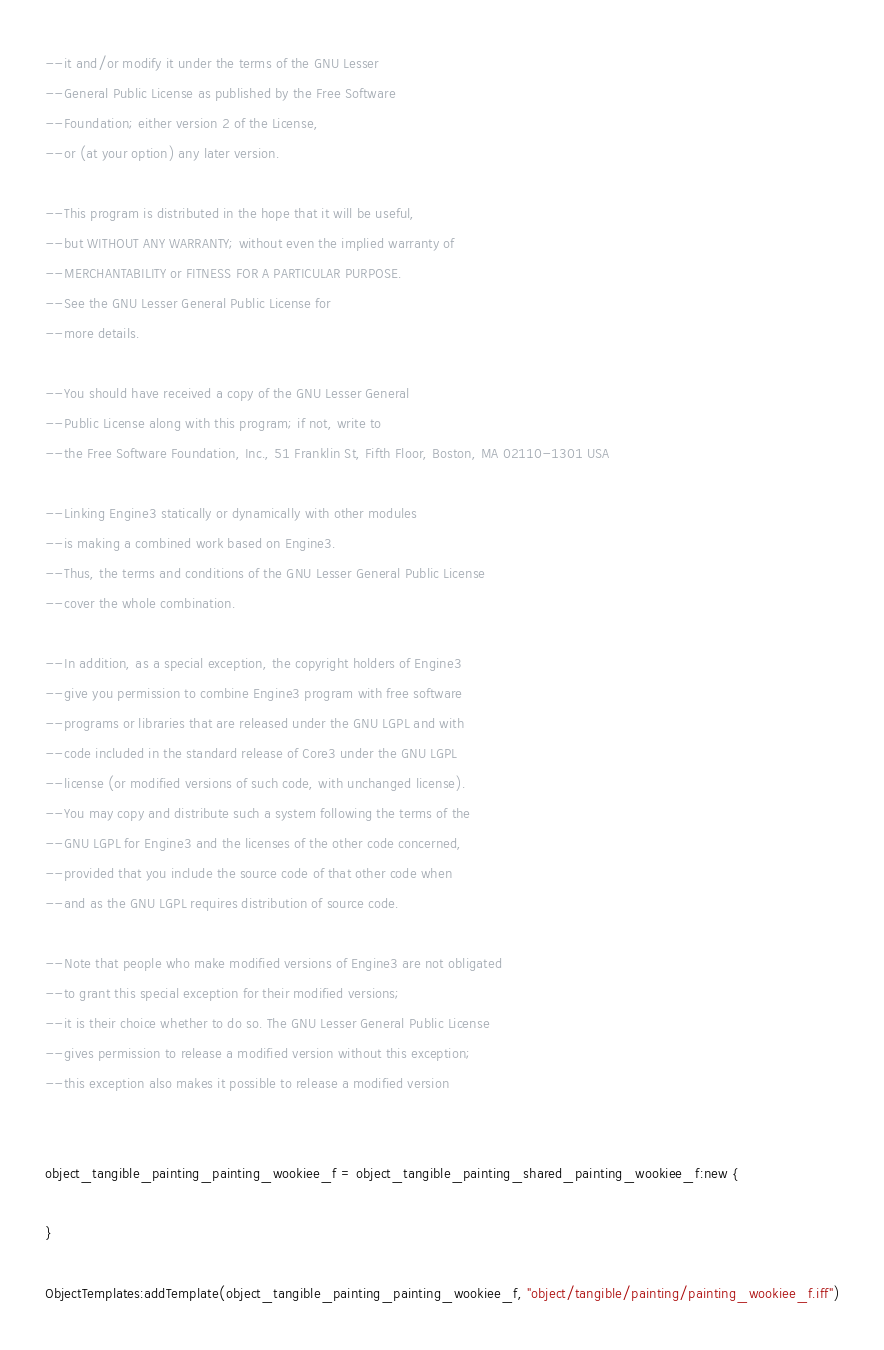<code> <loc_0><loc_0><loc_500><loc_500><_Lua_>--it and/or modify it under the terms of the GNU Lesser 
--General Public License as published by the Free Software
--Foundation; either version 2 of the License, 
--or (at your option) any later version.

--This program is distributed in the hope that it will be useful, 
--but WITHOUT ANY WARRANTY; without even the implied warranty of 
--MERCHANTABILITY or FITNESS FOR A PARTICULAR PURPOSE. 
--See the GNU Lesser General Public License for
--more details.

--You should have received a copy of the GNU Lesser General 
--Public License along with this program; if not, write to
--the Free Software Foundation, Inc., 51 Franklin St, Fifth Floor, Boston, MA 02110-1301 USA

--Linking Engine3 statically or dynamically with other modules 
--is making a combined work based on Engine3. 
--Thus, the terms and conditions of the GNU Lesser General Public License 
--cover the whole combination.

--In addition, as a special exception, the copyright holders of Engine3 
--give you permission to combine Engine3 program with free software 
--programs or libraries that are released under the GNU LGPL and with 
--code included in the standard release of Core3 under the GNU LGPL 
--license (or modified versions of such code, with unchanged license). 
--You may copy and distribute such a system following the terms of the 
--GNU LGPL for Engine3 and the licenses of the other code concerned, 
--provided that you include the source code of that other code when 
--and as the GNU LGPL requires distribution of source code.

--Note that people who make modified versions of Engine3 are not obligated 
--to grant this special exception for their modified versions; 
--it is their choice whether to do so. The GNU Lesser General Public License 
--gives permission to release a modified version without this exception; 
--this exception also makes it possible to release a modified version 


object_tangible_painting_painting_wookiee_f = object_tangible_painting_shared_painting_wookiee_f:new {

}

ObjectTemplates:addTemplate(object_tangible_painting_painting_wookiee_f, "object/tangible/painting/painting_wookiee_f.iff")
</code> 